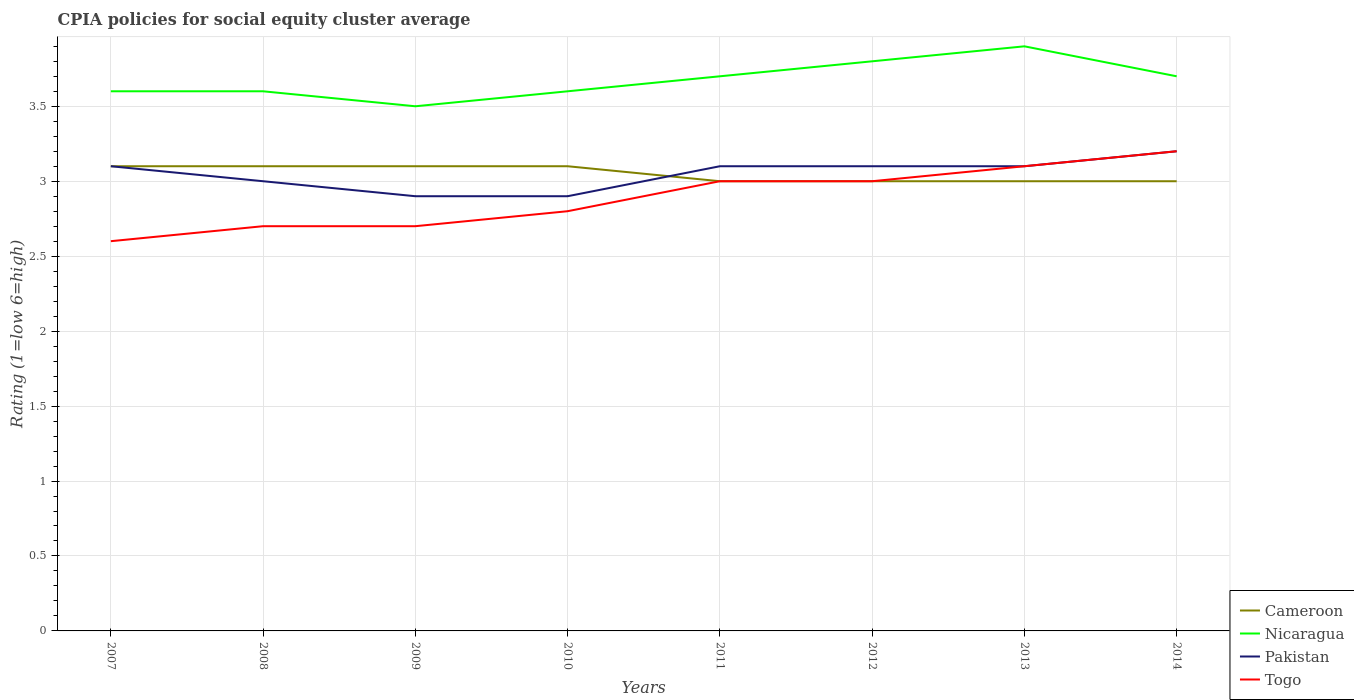How many different coloured lines are there?
Offer a terse response. 4. Does the line corresponding to Togo intersect with the line corresponding to Cameroon?
Make the answer very short. Yes. What is the difference between the highest and the second highest CPIA rating in Cameroon?
Your answer should be compact. 0.1. What is the difference between the highest and the lowest CPIA rating in Nicaragua?
Keep it short and to the point. 4. How many lines are there?
Offer a very short reply. 4. Are the values on the major ticks of Y-axis written in scientific E-notation?
Offer a terse response. No. Does the graph contain any zero values?
Your response must be concise. No. Does the graph contain grids?
Your response must be concise. Yes. How many legend labels are there?
Your response must be concise. 4. How are the legend labels stacked?
Provide a succinct answer. Vertical. What is the title of the graph?
Your answer should be very brief. CPIA policies for social equity cluster average. What is the label or title of the X-axis?
Your response must be concise. Years. What is the Rating (1=low 6=high) of Cameroon in 2007?
Provide a short and direct response. 3.1. What is the Rating (1=low 6=high) of Nicaragua in 2007?
Ensure brevity in your answer.  3.6. What is the Rating (1=low 6=high) in Togo in 2007?
Ensure brevity in your answer.  2.6. What is the Rating (1=low 6=high) of Cameroon in 2008?
Offer a very short reply. 3.1. What is the Rating (1=low 6=high) of Togo in 2008?
Offer a terse response. 2.7. What is the Rating (1=low 6=high) in Cameroon in 2009?
Your response must be concise. 3.1. What is the Rating (1=low 6=high) in Nicaragua in 2009?
Your response must be concise. 3.5. What is the Rating (1=low 6=high) in Pakistan in 2009?
Make the answer very short. 2.9. What is the Rating (1=low 6=high) in Togo in 2009?
Your answer should be compact. 2.7. What is the Rating (1=low 6=high) of Cameroon in 2010?
Make the answer very short. 3.1. What is the Rating (1=low 6=high) of Nicaragua in 2010?
Ensure brevity in your answer.  3.6. What is the Rating (1=low 6=high) of Togo in 2010?
Give a very brief answer. 2.8. What is the Rating (1=low 6=high) of Nicaragua in 2011?
Provide a short and direct response. 3.7. What is the Rating (1=low 6=high) of Nicaragua in 2012?
Your answer should be very brief. 3.8. What is the Rating (1=low 6=high) of Pakistan in 2012?
Provide a short and direct response. 3.1. What is the Rating (1=low 6=high) in Togo in 2012?
Offer a very short reply. 3. What is the Rating (1=low 6=high) of Cameroon in 2013?
Provide a succinct answer. 3. What is the Rating (1=low 6=high) in Nicaragua in 2014?
Your answer should be compact. 3.7. Across all years, what is the maximum Rating (1=low 6=high) in Nicaragua?
Provide a short and direct response. 3.9. Across all years, what is the minimum Rating (1=low 6=high) of Togo?
Make the answer very short. 2.6. What is the total Rating (1=low 6=high) in Cameroon in the graph?
Offer a very short reply. 24.4. What is the total Rating (1=low 6=high) of Nicaragua in the graph?
Provide a short and direct response. 29.4. What is the total Rating (1=low 6=high) of Pakistan in the graph?
Your answer should be compact. 24.4. What is the total Rating (1=low 6=high) of Togo in the graph?
Offer a very short reply. 23.1. What is the difference between the Rating (1=low 6=high) of Cameroon in 2007 and that in 2009?
Ensure brevity in your answer.  0. What is the difference between the Rating (1=low 6=high) in Togo in 2007 and that in 2009?
Your response must be concise. -0.1. What is the difference between the Rating (1=low 6=high) in Cameroon in 2007 and that in 2010?
Ensure brevity in your answer.  0. What is the difference between the Rating (1=low 6=high) of Cameroon in 2007 and that in 2011?
Provide a short and direct response. 0.1. What is the difference between the Rating (1=low 6=high) in Pakistan in 2007 and that in 2011?
Your answer should be compact. 0. What is the difference between the Rating (1=low 6=high) of Togo in 2007 and that in 2011?
Offer a very short reply. -0.4. What is the difference between the Rating (1=low 6=high) of Cameroon in 2007 and that in 2012?
Offer a very short reply. 0.1. What is the difference between the Rating (1=low 6=high) in Nicaragua in 2007 and that in 2012?
Your answer should be compact. -0.2. What is the difference between the Rating (1=low 6=high) in Pakistan in 2007 and that in 2012?
Ensure brevity in your answer.  0. What is the difference between the Rating (1=low 6=high) in Nicaragua in 2007 and that in 2013?
Keep it short and to the point. -0.3. What is the difference between the Rating (1=low 6=high) of Cameroon in 2007 and that in 2014?
Provide a succinct answer. 0.1. What is the difference between the Rating (1=low 6=high) in Cameroon in 2008 and that in 2009?
Provide a succinct answer. 0. What is the difference between the Rating (1=low 6=high) in Nicaragua in 2008 and that in 2009?
Make the answer very short. 0.1. What is the difference between the Rating (1=low 6=high) in Togo in 2008 and that in 2009?
Provide a succinct answer. 0. What is the difference between the Rating (1=low 6=high) in Nicaragua in 2008 and that in 2010?
Make the answer very short. 0. What is the difference between the Rating (1=low 6=high) of Cameroon in 2008 and that in 2011?
Ensure brevity in your answer.  0.1. What is the difference between the Rating (1=low 6=high) in Cameroon in 2008 and that in 2012?
Make the answer very short. 0.1. What is the difference between the Rating (1=low 6=high) in Pakistan in 2008 and that in 2012?
Make the answer very short. -0.1. What is the difference between the Rating (1=low 6=high) of Togo in 2008 and that in 2012?
Your answer should be very brief. -0.3. What is the difference between the Rating (1=low 6=high) of Cameroon in 2008 and that in 2013?
Keep it short and to the point. 0.1. What is the difference between the Rating (1=low 6=high) of Pakistan in 2008 and that in 2013?
Keep it short and to the point. -0.1. What is the difference between the Rating (1=low 6=high) in Cameroon in 2008 and that in 2014?
Your answer should be compact. 0.1. What is the difference between the Rating (1=low 6=high) in Nicaragua in 2008 and that in 2014?
Provide a succinct answer. -0.1. What is the difference between the Rating (1=low 6=high) in Pakistan in 2009 and that in 2010?
Your response must be concise. 0. What is the difference between the Rating (1=low 6=high) of Cameroon in 2009 and that in 2011?
Keep it short and to the point. 0.1. What is the difference between the Rating (1=low 6=high) in Nicaragua in 2009 and that in 2011?
Provide a succinct answer. -0.2. What is the difference between the Rating (1=low 6=high) of Pakistan in 2009 and that in 2011?
Make the answer very short. -0.2. What is the difference between the Rating (1=low 6=high) of Togo in 2009 and that in 2011?
Your response must be concise. -0.3. What is the difference between the Rating (1=low 6=high) in Cameroon in 2009 and that in 2012?
Offer a very short reply. 0.1. What is the difference between the Rating (1=low 6=high) in Nicaragua in 2009 and that in 2012?
Keep it short and to the point. -0.3. What is the difference between the Rating (1=low 6=high) in Pakistan in 2009 and that in 2012?
Provide a short and direct response. -0.2. What is the difference between the Rating (1=low 6=high) of Nicaragua in 2009 and that in 2013?
Make the answer very short. -0.4. What is the difference between the Rating (1=low 6=high) of Pakistan in 2009 and that in 2013?
Offer a terse response. -0.2. What is the difference between the Rating (1=low 6=high) of Togo in 2009 and that in 2013?
Provide a succinct answer. -0.4. What is the difference between the Rating (1=low 6=high) of Pakistan in 2009 and that in 2014?
Ensure brevity in your answer.  -0.3. What is the difference between the Rating (1=low 6=high) in Togo in 2009 and that in 2014?
Give a very brief answer. -0.5. What is the difference between the Rating (1=low 6=high) of Nicaragua in 2010 and that in 2011?
Keep it short and to the point. -0.1. What is the difference between the Rating (1=low 6=high) in Pakistan in 2010 and that in 2011?
Your answer should be very brief. -0.2. What is the difference between the Rating (1=low 6=high) of Togo in 2010 and that in 2011?
Provide a succinct answer. -0.2. What is the difference between the Rating (1=low 6=high) in Nicaragua in 2010 and that in 2012?
Provide a short and direct response. -0.2. What is the difference between the Rating (1=low 6=high) in Nicaragua in 2010 and that in 2013?
Your answer should be very brief. -0.3. What is the difference between the Rating (1=low 6=high) in Pakistan in 2010 and that in 2013?
Offer a very short reply. -0.2. What is the difference between the Rating (1=low 6=high) of Cameroon in 2010 and that in 2014?
Offer a terse response. 0.1. What is the difference between the Rating (1=low 6=high) of Pakistan in 2010 and that in 2014?
Your answer should be very brief. -0.3. What is the difference between the Rating (1=low 6=high) of Cameroon in 2011 and that in 2012?
Provide a short and direct response. 0. What is the difference between the Rating (1=low 6=high) of Nicaragua in 2011 and that in 2012?
Your answer should be very brief. -0.1. What is the difference between the Rating (1=low 6=high) of Pakistan in 2011 and that in 2012?
Make the answer very short. 0. What is the difference between the Rating (1=low 6=high) in Togo in 2011 and that in 2012?
Provide a succinct answer. 0. What is the difference between the Rating (1=low 6=high) of Cameroon in 2011 and that in 2014?
Ensure brevity in your answer.  0. What is the difference between the Rating (1=low 6=high) in Togo in 2012 and that in 2013?
Keep it short and to the point. -0.1. What is the difference between the Rating (1=low 6=high) of Cameroon in 2012 and that in 2014?
Provide a succinct answer. 0. What is the difference between the Rating (1=low 6=high) in Nicaragua in 2012 and that in 2014?
Keep it short and to the point. 0.1. What is the difference between the Rating (1=low 6=high) of Togo in 2012 and that in 2014?
Ensure brevity in your answer.  -0.2. What is the difference between the Rating (1=low 6=high) of Nicaragua in 2013 and that in 2014?
Keep it short and to the point. 0.2. What is the difference between the Rating (1=low 6=high) of Pakistan in 2013 and that in 2014?
Your answer should be very brief. -0.1. What is the difference between the Rating (1=low 6=high) of Togo in 2013 and that in 2014?
Offer a terse response. -0.1. What is the difference between the Rating (1=low 6=high) of Cameroon in 2007 and the Rating (1=low 6=high) of Pakistan in 2008?
Give a very brief answer. 0.1. What is the difference between the Rating (1=low 6=high) of Cameroon in 2007 and the Rating (1=low 6=high) of Togo in 2008?
Offer a terse response. 0.4. What is the difference between the Rating (1=low 6=high) of Nicaragua in 2007 and the Rating (1=low 6=high) of Pakistan in 2008?
Offer a terse response. 0.6. What is the difference between the Rating (1=low 6=high) of Nicaragua in 2007 and the Rating (1=low 6=high) of Togo in 2008?
Provide a short and direct response. 0.9. What is the difference between the Rating (1=low 6=high) in Cameroon in 2007 and the Rating (1=low 6=high) in Nicaragua in 2010?
Your answer should be very brief. -0.5. What is the difference between the Rating (1=low 6=high) of Cameroon in 2007 and the Rating (1=low 6=high) of Togo in 2010?
Provide a short and direct response. 0.3. What is the difference between the Rating (1=low 6=high) of Nicaragua in 2007 and the Rating (1=low 6=high) of Togo in 2010?
Give a very brief answer. 0.8. What is the difference between the Rating (1=low 6=high) in Pakistan in 2007 and the Rating (1=low 6=high) in Togo in 2010?
Offer a very short reply. 0.3. What is the difference between the Rating (1=low 6=high) in Nicaragua in 2007 and the Rating (1=low 6=high) in Pakistan in 2011?
Your answer should be very brief. 0.5. What is the difference between the Rating (1=low 6=high) of Cameroon in 2007 and the Rating (1=low 6=high) of Nicaragua in 2012?
Ensure brevity in your answer.  -0.7. What is the difference between the Rating (1=low 6=high) of Cameroon in 2007 and the Rating (1=low 6=high) of Togo in 2012?
Your answer should be very brief. 0.1. What is the difference between the Rating (1=low 6=high) in Pakistan in 2007 and the Rating (1=low 6=high) in Togo in 2012?
Keep it short and to the point. 0.1. What is the difference between the Rating (1=low 6=high) in Cameroon in 2007 and the Rating (1=low 6=high) in Pakistan in 2013?
Provide a short and direct response. 0. What is the difference between the Rating (1=low 6=high) of Cameroon in 2007 and the Rating (1=low 6=high) of Togo in 2013?
Give a very brief answer. 0. What is the difference between the Rating (1=low 6=high) in Nicaragua in 2007 and the Rating (1=low 6=high) in Pakistan in 2013?
Your answer should be compact. 0.5. What is the difference between the Rating (1=low 6=high) of Pakistan in 2007 and the Rating (1=low 6=high) of Togo in 2013?
Keep it short and to the point. 0. What is the difference between the Rating (1=low 6=high) of Cameroon in 2007 and the Rating (1=low 6=high) of Nicaragua in 2014?
Provide a short and direct response. -0.6. What is the difference between the Rating (1=low 6=high) in Cameroon in 2007 and the Rating (1=low 6=high) in Togo in 2014?
Keep it short and to the point. -0.1. What is the difference between the Rating (1=low 6=high) in Nicaragua in 2007 and the Rating (1=low 6=high) in Togo in 2014?
Your response must be concise. 0.4. What is the difference between the Rating (1=low 6=high) in Pakistan in 2007 and the Rating (1=low 6=high) in Togo in 2014?
Ensure brevity in your answer.  -0.1. What is the difference between the Rating (1=low 6=high) of Cameroon in 2008 and the Rating (1=low 6=high) of Pakistan in 2009?
Your answer should be compact. 0.2. What is the difference between the Rating (1=low 6=high) in Cameroon in 2008 and the Rating (1=low 6=high) in Togo in 2009?
Offer a terse response. 0.4. What is the difference between the Rating (1=low 6=high) in Nicaragua in 2008 and the Rating (1=low 6=high) in Togo in 2009?
Your answer should be compact. 0.9. What is the difference between the Rating (1=low 6=high) of Pakistan in 2008 and the Rating (1=low 6=high) of Togo in 2009?
Your answer should be very brief. 0.3. What is the difference between the Rating (1=low 6=high) in Nicaragua in 2008 and the Rating (1=low 6=high) in Pakistan in 2010?
Your answer should be compact. 0.7. What is the difference between the Rating (1=low 6=high) in Pakistan in 2008 and the Rating (1=low 6=high) in Togo in 2010?
Make the answer very short. 0.2. What is the difference between the Rating (1=low 6=high) of Cameroon in 2008 and the Rating (1=low 6=high) of Pakistan in 2011?
Offer a terse response. 0. What is the difference between the Rating (1=low 6=high) in Cameroon in 2008 and the Rating (1=low 6=high) in Togo in 2011?
Ensure brevity in your answer.  0.1. What is the difference between the Rating (1=low 6=high) in Nicaragua in 2008 and the Rating (1=low 6=high) in Togo in 2011?
Provide a short and direct response. 0.6. What is the difference between the Rating (1=low 6=high) of Cameroon in 2008 and the Rating (1=low 6=high) of Nicaragua in 2012?
Keep it short and to the point. -0.7. What is the difference between the Rating (1=low 6=high) in Cameroon in 2008 and the Rating (1=low 6=high) in Pakistan in 2012?
Your response must be concise. 0. What is the difference between the Rating (1=low 6=high) in Cameroon in 2008 and the Rating (1=low 6=high) in Togo in 2012?
Your response must be concise. 0.1. What is the difference between the Rating (1=low 6=high) in Nicaragua in 2008 and the Rating (1=low 6=high) in Togo in 2012?
Ensure brevity in your answer.  0.6. What is the difference between the Rating (1=low 6=high) of Pakistan in 2008 and the Rating (1=low 6=high) of Togo in 2012?
Provide a succinct answer. 0. What is the difference between the Rating (1=low 6=high) of Cameroon in 2008 and the Rating (1=low 6=high) of Nicaragua in 2013?
Make the answer very short. -0.8. What is the difference between the Rating (1=low 6=high) of Nicaragua in 2008 and the Rating (1=low 6=high) of Togo in 2013?
Give a very brief answer. 0.5. What is the difference between the Rating (1=low 6=high) of Pakistan in 2008 and the Rating (1=low 6=high) of Togo in 2013?
Provide a succinct answer. -0.1. What is the difference between the Rating (1=low 6=high) of Cameroon in 2008 and the Rating (1=low 6=high) of Togo in 2014?
Provide a succinct answer. -0.1. What is the difference between the Rating (1=low 6=high) in Pakistan in 2008 and the Rating (1=low 6=high) in Togo in 2014?
Your answer should be very brief. -0.2. What is the difference between the Rating (1=low 6=high) in Cameroon in 2009 and the Rating (1=low 6=high) in Pakistan in 2010?
Your answer should be compact. 0.2. What is the difference between the Rating (1=low 6=high) in Cameroon in 2009 and the Rating (1=low 6=high) in Togo in 2010?
Ensure brevity in your answer.  0.3. What is the difference between the Rating (1=low 6=high) in Pakistan in 2009 and the Rating (1=low 6=high) in Togo in 2010?
Your response must be concise. 0.1. What is the difference between the Rating (1=low 6=high) of Nicaragua in 2009 and the Rating (1=low 6=high) of Pakistan in 2011?
Ensure brevity in your answer.  0.4. What is the difference between the Rating (1=low 6=high) in Pakistan in 2009 and the Rating (1=low 6=high) in Togo in 2011?
Your response must be concise. -0.1. What is the difference between the Rating (1=low 6=high) of Cameroon in 2009 and the Rating (1=low 6=high) of Pakistan in 2012?
Offer a very short reply. 0. What is the difference between the Rating (1=low 6=high) of Cameroon in 2009 and the Rating (1=low 6=high) of Togo in 2012?
Make the answer very short. 0.1. What is the difference between the Rating (1=low 6=high) of Nicaragua in 2009 and the Rating (1=low 6=high) of Togo in 2012?
Make the answer very short. 0.5. What is the difference between the Rating (1=low 6=high) of Cameroon in 2009 and the Rating (1=low 6=high) of Nicaragua in 2013?
Make the answer very short. -0.8. What is the difference between the Rating (1=low 6=high) in Nicaragua in 2009 and the Rating (1=low 6=high) in Pakistan in 2013?
Give a very brief answer. 0.4. What is the difference between the Rating (1=low 6=high) of Nicaragua in 2009 and the Rating (1=low 6=high) of Togo in 2013?
Give a very brief answer. 0.4. What is the difference between the Rating (1=low 6=high) of Pakistan in 2009 and the Rating (1=low 6=high) of Togo in 2013?
Your answer should be very brief. -0.2. What is the difference between the Rating (1=low 6=high) of Cameroon in 2009 and the Rating (1=low 6=high) of Nicaragua in 2014?
Ensure brevity in your answer.  -0.6. What is the difference between the Rating (1=low 6=high) in Cameroon in 2009 and the Rating (1=low 6=high) in Pakistan in 2014?
Offer a very short reply. -0.1. What is the difference between the Rating (1=low 6=high) of Cameroon in 2009 and the Rating (1=low 6=high) of Togo in 2014?
Your answer should be compact. -0.1. What is the difference between the Rating (1=low 6=high) of Cameroon in 2010 and the Rating (1=low 6=high) of Nicaragua in 2011?
Ensure brevity in your answer.  -0.6. What is the difference between the Rating (1=low 6=high) of Cameroon in 2010 and the Rating (1=low 6=high) of Pakistan in 2011?
Your answer should be very brief. 0. What is the difference between the Rating (1=low 6=high) of Nicaragua in 2010 and the Rating (1=low 6=high) of Pakistan in 2011?
Provide a succinct answer. 0.5. What is the difference between the Rating (1=low 6=high) of Pakistan in 2010 and the Rating (1=low 6=high) of Togo in 2011?
Make the answer very short. -0.1. What is the difference between the Rating (1=low 6=high) in Cameroon in 2010 and the Rating (1=low 6=high) in Nicaragua in 2012?
Make the answer very short. -0.7. What is the difference between the Rating (1=low 6=high) in Nicaragua in 2010 and the Rating (1=low 6=high) in Pakistan in 2012?
Provide a succinct answer. 0.5. What is the difference between the Rating (1=low 6=high) of Nicaragua in 2010 and the Rating (1=low 6=high) of Togo in 2012?
Ensure brevity in your answer.  0.6. What is the difference between the Rating (1=low 6=high) of Cameroon in 2010 and the Rating (1=low 6=high) of Nicaragua in 2014?
Make the answer very short. -0.6. What is the difference between the Rating (1=low 6=high) in Cameroon in 2010 and the Rating (1=low 6=high) in Pakistan in 2014?
Make the answer very short. -0.1. What is the difference between the Rating (1=low 6=high) in Cameroon in 2010 and the Rating (1=low 6=high) in Togo in 2014?
Provide a succinct answer. -0.1. What is the difference between the Rating (1=low 6=high) in Pakistan in 2010 and the Rating (1=low 6=high) in Togo in 2014?
Ensure brevity in your answer.  -0.3. What is the difference between the Rating (1=low 6=high) in Cameroon in 2011 and the Rating (1=low 6=high) in Nicaragua in 2012?
Provide a short and direct response. -0.8. What is the difference between the Rating (1=low 6=high) of Cameroon in 2011 and the Rating (1=low 6=high) of Pakistan in 2012?
Provide a short and direct response. -0.1. What is the difference between the Rating (1=low 6=high) of Cameroon in 2011 and the Rating (1=low 6=high) of Togo in 2012?
Make the answer very short. 0. What is the difference between the Rating (1=low 6=high) in Nicaragua in 2011 and the Rating (1=low 6=high) in Pakistan in 2012?
Your response must be concise. 0.6. What is the difference between the Rating (1=low 6=high) in Nicaragua in 2011 and the Rating (1=low 6=high) in Togo in 2012?
Offer a very short reply. 0.7. What is the difference between the Rating (1=low 6=high) in Cameroon in 2011 and the Rating (1=low 6=high) in Nicaragua in 2013?
Your answer should be very brief. -0.9. What is the difference between the Rating (1=low 6=high) in Cameroon in 2011 and the Rating (1=low 6=high) in Togo in 2013?
Keep it short and to the point. -0.1. What is the difference between the Rating (1=low 6=high) of Cameroon in 2011 and the Rating (1=low 6=high) of Nicaragua in 2014?
Your answer should be compact. -0.7. What is the difference between the Rating (1=low 6=high) in Cameroon in 2011 and the Rating (1=low 6=high) in Togo in 2014?
Offer a very short reply. -0.2. What is the difference between the Rating (1=low 6=high) in Nicaragua in 2011 and the Rating (1=low 6=high) in Pakistan in 2014?
Provide a short and direct response. 0.5. What is the difference between the Rating (1=low 6=high) of Nicaragua in 2012 and the Rating (1=low 6=high) of Pakistan in 2013?
Your response must be concise. 0.7. What is the difference between the Rating (1=low 6=high) of Nicaragua in 2012 and the Rating (1=low 6=high) of Togo in 2013?
Offer a terse response. 0.7. What is the difference between the Rating (1=low 6=high) in Pakistan in 2012 and the Rating (1=low 6=high) in Togo in 2013?
Your answer should be very brief. 0. What is the difference between the Rating (1=low 6=high) of Cameroon in 2012 and the Rating (1=low 6=high) of Nicaragua in 2014?
Provide a succinct answer. -0.7. What is the difference between the Rating (1=low 6=high) of Cameroon in 2012 and the Rating (1=low 6=high) of Togo in 2014?
Provide a succinct answer. -0.2. What is the difference between the Rating (1=low 6=high) of Nicaragua in 2012 and the Rating (1=low 6=high) of Pakistan in 2014?
Keep it short and to the point. 0.6. What is the difference between the Rating (1=low 6=high) in Nicaragua in 2012 and the Rating (1=low 6=high) in Togo in 2014?
Offer a terse response. 0.6. What is the difference between the Rating (1=low 6=high) in Cameroon in 2013 and the Rating (1=low 6=high) in Nicaragua in 2014?
Your response must be concise. -0.7. What is the difference between the Rating (1=low 6=high) of Nicaragua in 2013 and the Rating (1=low 6=high) of Pakistan in 2014?
Give a very brief answer. 0.7. What is the difference between the Rating (1=low 6=high) in Pakistan in 2013 and the Rating (1=low 6=high) in Togo in 2014?
Your answer should be very brief. -0.1. What is the average Rating (1=low 6=high) in Cameroon per year?
Keep it short and to the point. 3.05. What is the average Rating (1=low 6=high) in Nicaragua per year?
Ensure brevity in your answer.  3.67. What is the average Rating (1=low 6=high) of Pakistan per year?
Provide a short and direct response. 3.05. What is the average Rating (1=low 6=high) of Togo per year?
Offer a very short reply. 2.89. In the year 2007, what is the difference between the Rating (1=low 6=high) in Cameroon and Rating (1=low 6=high) in Togo?
Keep it short and to the point. 0.5. In the year 2008, what is the difference between the Rating (1=low 6=high) of Cameroon and Rating (1=low 6=high) of Nicaragua?
Offer a very short reply. -0.5. In the year 2008, what is the difference between the Rating (1=low 6=high) of Cameroon and Rating (1=low 6=high) of Pakistan?
Provide a succinct answer. 0.1. In the year 2008, what is the difference between the Rating (1=low 6=high) of Nicaragua and Rating (1=low 6=high) of Togo?
Provide a succinct answer. 0.9. In the year 2009, what is the difference between the Rating (1=low 6=high) in Cameroon and Rating (1=low 6=high) in Nicaragua?
Your answer should be compact. -0.4. In the year 2009, what is the difference between the Rating (1=low 6=high) in Cameroon and Rating (1=low 6=high) in Pakistan?
Offer a very short reply. 0.2. In the year 2009, what is the difference between the Rating (1=low 6=high) in Cameroon and Rating (1=low 6=high) in Togo?
Provide a succinct answer. 0.4. In the year 2009, what is the difference between the Rating (1=low 6=high) in Nicaragua and Rating (1=low 6=high) in Pakistan?
Your answer should be compact. 0.6. In the year 2009, what is the difference between the Rating (1=low 6=high) of Nicaragua and Rating (1=low 6=high) of Togo?
Provide a short and direct response. 0.8. In the year 2010, what is the difference between the Rating (1=low 6=high) in Cameroon and Rating (1=low 6=high) in Pakistan?
Provide a short and direct response. 0.2. In the year 2010, what is the difference between the Rating (1=low 6=high) of Cameroon and Rating (1=low 6=high) of Togo?
Your answer should be very brief. 0.3. In the year 2010, what is the difference between the Rating (1=low 6=high) in Nicaragua and Rating (1=low 6=high) in Pakistan?
Your answer should be very brief. 0.7. In the year 2010, what is the difference between the Rating (1=low 6=high) of Nicaragua and Rating (1=low 6=high) of Togo?
Provide a short and direct response. 0.8. In the year 2010, what is the difference between the Rating (1=low 6=high) in Pakistan and Rating (1=low 6=high) in Togo?
Offer a very short reply. 0.1. In the year 2011, what is the difference between the Rating (1=low 6=high) of Cameroon and Rating (1=low 6=high) of Pakistan?
Your answer should be very brief. -0.1. In the year 2011, what is the difference between the Rating (1=low 6=high) in Nicaragua and Rating (1=low 6=high) in Pakistan?
Keep it short and to the point. 0.6. In the year 2012, what is the difference between the Rating (1=low 6=high) of Cameroon and Rating (1=low 6=high) of Pakistan?
Keep it short and to the point. -0.1. In the year 2012, what is the difference between the Rating (1=low 6=high) in Nicaragua and Rating (1=low 6=high) in Pakistan?
Keep it short and to the point. 0.7. In the year 2012, what is the difference between the Rating (1=low 6=high) of Nicaragua and Rating (1=low 6=high) of Togo?
Your answer should be compact. 0.8. In the year 2012, what is the difference between the Rating (1=low 6=high) of Pakistan and Rating (1=low 6=high) of Togo?
Keep it short and to the point. 0.1. In the year 2013, what is the difference between the Rating (1=low 6=high) in Cameroon and Rating (1=low 6=high) in Nicaragua?
Your answer should be very brief. -0.9. In the year 2013, what is the difference between the Rating (1=low 6=high) in Cameroon and Rating (1=low 6=high) in Pakistan?
Provide a succinct answer. -0.1. In the year 2013, what is the difference between the Rating (1=low 6=high) of Nicaragua and Rating (1=low 6=high) of Pakistan?
Make the answer very short. 0.8. In the year 2013, what is the difference between the Rating (1=low 6=high) in Nicaragua and Rating (1=low 6=high) in Togo?
Make the answer very short. 0.8. In the year 2013, what is the difference between the Rating (1=low 6=high) of Pakistan and Rating (1=low 6=high) of Togo?
Provide a short and direct response. 0. In the year 2014, what is the difference between the Rating (1=low 6=high) of Cameroon and Rating (1=low 6=high) of Nicaragua?
Keep it short and to the point. -0.7. In the year 2014, what is the difference between the Rating (1=low 6=high) of Cameroon and Rating (1=low 6=high) of Pakistan?
Provide a succinct answer. -0.2. In the year 2014, what is the difference between the Rating (1=low 6=high) of Cameroon and Rating (1=low 6=high) of Togo?
Your response must be concise. -0.2. In the year 2014, what is the difference between the Rating (1=low 6=high) of Nicaragua and Rating (1=low 6=high) of Togo?
Offer a very short reply. 0.5. In the year 2014, what is the difference between the Rating (1=low 6=high) in Pakistan and Rating (1=low 6=high) in Togo?
Provide a succinct answer. 0. What is the ratio of the Rating (1=low 6=high) of Pakistan in 2007 to that in 2008?
Provide a short and direct response. 1.03. What is the ratio of the Rating (1=low 6=high) in Nicaragua in 2007 to that in 2009?
Offer a terse response. 1.03. What is the ratio of the Rating (1=low 6=high) of Pakistan in 2007 to that in 2009?
Your response must be concise. 1.07. What is the ratio of the Rating (1=low 6=high) of Togo in 2007 to that in 2009?
Offer a very short reply. 0.96. What is the ratio of the Rating (1=low 6=high) of Pakistan in 2007 to that in 2010?
Provide a short and direct response. 1.07. What is the ratio of the Rating (1=low 6=high) of Togo in 2007 to that in 2010?
Make the answer very short. 0.93. What is the ratio of the Rating (1=low 6=high) of Cameroon in 2007 to that in 2011?
Ensure brevity in your answer.  1.03. What is the ratio of the Rating (1=low 6=high) in Nicaragua in 2007 to that in 2011?
Your answer should be compact. 0.97. What is the ratio of the Rating (1=low 6=high) of Pakistan in 2007 to that in 2011?
Give a very brief answer. 1. What is the ratio of the Rating (1=low 6=high) in Togo in 2007 to that in 2011?
Your answer should be compact. 0.87. What is the ratio of the Rating (1=low 6=high) of Nicaragua in 2007 to that in 2012?
Provide a short and direct response. 0.95. What is the ratio of the Rating (1=low 6=high) in Pakistan in 2007 to that in 2012?
Ensure brevity in your answer.  1. What is the ratio of the Rating (1=low 6=high) of Togo in 2007 to that in 2012?
Keep it short and to the point. 0.87. What is the ratio of the Rating (1=low 6=high) of Nicaragua in 2007 to that in 2013?
Give a very brief answer. 0.92. What is the ratio of the Rating (1=low 6=high) of Pakistan in 2007 to that in 2013?
Provide a short and direct response. 1. What is the ratio of the Rating (1=low 6=high) in Togo in 2007 to that in 2013?
Make the answer very short. 0.84. What is the ratio of the Rating (1=low 6=high) in Nicaragua in 2007 to that in 2014?
Your answer should be very brief. 0.97. What is the ratio of the Rating (1=low 6=high) in Pakistan in 2007 to that in 2014?
Your answer should be compact. 0.97. What is the ratio of the Rating (1=low 6=high) in Togo in 2007 to that in 2014?
Your answer should be compact. 0.81. What is the ratio of the Rating (1=low 6=high) in Cameroon in 2008 to that in 2009?
Provide a short and direct response. 1. What is the ratio of the Rating (1=low 6=high) in Nicaragua in 2008 to that in 2009?
Keep it short and to the point. 1.03. What is the ratio of the Rating (1=low 6=high) in Pakistan in 2008 to that in 2009?
Give a very brief answer. 1.03. What is the ratio of the Rating (1=low 6=high) of Togo in 2008 to that in 2009?
Offer a very short reply. 1. What is the ratio of the Rating (1=low 6=high) in Nicaragua in 2008 to that in 2010?
Offer a very short reply. 1. What is the ratio of the Rating (1=low 6=high) of Pakistan in 2008 to that in 2010?
Ensure brevity in your answer.  1.03. What is the ratio of the Rating (1=low 6=high) in Togo in 2008 to that in 2010?
Keep it short and to the point. 0.96. What is the ratio of the Rating (1=low 6=high) of Cameroon in 2008 to that in 2011?
Your answer should be compact. 1.03. What is the ratio of the Rating (1=low 6=high) in Nicaragua in 2008 to that in 2011?
Your answer should be very brief. 0.97. What is the ratio of the Rating (1=low 6=high) of Togo in 2008 to that in 2011?
Keep it short and to the point. 0.9. What is the ratio of the Rating (1=low 6=high) in Pakistan in 2008 to that in 2012?
Offer a terse response. 0.97. What is the ratio of the Rating (1=low 6=high) in Nicaragua in 2008 to that in 2013?
Provide a short and direct response. 0.92. What is the ratio of the Rating (1=low 6=high) of Pakistan in 2008 to that in 2013?
Keep it short and to the point. 0.97. What is the ratio of the Rating (1=low 6=high) in Togo in 2008 to that in 2013?
Your answer should be compact. 0.87. What is the ratio of the Rating (1=low 6=high) in Cameroon in 2008 to that in 2014?
Your answer should be compact. 1.03. What is the ratio of the Rating (1=low 6=high) of Pakistan in 2008 to that in 2014?
Offer a terse response. 0.94. What is the ratio of the Rating (1=low 6=high) in Togo in 2008 to that in 2014?
Your answer should be very brief. 0.84. What is the ratio of the Rating (1=low 6=high) of Nicaragua in 2009 to that in 2010?
Ensure brevity in your answer.  0.97. What is the ratio of the Rating (1=low 6=high) in Pakistan in 2009 to that in 2010?
Offer a terse response. 1. What is the ratio of the Rating (1=low 6=high) in Nicaragua in 2009 to that in 2011?
Offer a terse response. 0.95. What is the ratio of the Rating (1=low 6=high) in Pakistan in 2009 to that in 2011?
Make the answer very short. 0.94. What is the ratio of the Rating (1=low 6=high) in Togo in 2009 to that in 2011?
Provide a succinct answer. 0.9. What is the ratio of the Rating (1=low 6=high) of Nicaragua in 2009 to that in 2012?
Your answer should be very brief. 0.92. What is the ratio of the Rating (1=low 6=high) in Pakistan in 2009 to that in 2012?
Make the answer very short. 0.94. What is the ratio of the Rating (1=low 6=high) in Togo in 2009 to that in 2012?
Provide a succinct answer. 0.9. What is the ratio of the Rating (1=low 6=high) of Nicaragua in 2009 to that in 2013?
Give a very brief answer. 0.9. What is the ratio of the Rating (1=low 6=high) in Pakistan in 2009 to that in 2013?
Provide a succinct answer. 0.94. What is the ratio of the Rating (1=low 6=high) in Togo in 2009 to that in 2013?
Give a very brief answer. 0.87. What is the ratio of the Rating (1=low 6=high) of Nicaragua in 2009 to that in 2014?
Your answer should be compact. 0.95. What is the ratio of the Rating (1=low 6=high) of Pakistan in 2009 to that in 2014?
Make the answer very short. 0.91. What is the ratio of the Rating (1=low 6=high) of Togo in 2009 to that in 2014?
Offer a very short reply. 0.84. What is the ratio of the Rating (1=low 6=high) in Cameroon in 2010 to that in 2011?
Provide a short and direct response. 1.03. What is the ratio of the Rating (1=low 6=high) of Nicaragua in 2010 to that in 2011?
Provide a succinct answer. 0.97. What is the ratio of the Rating (1=low 6=high) of Pakistan in 2010 to that in 2011?
Provide a succinct answer. 0.94. What is the ratio of the Rating (1=low 6=high) of Togo in 2010 to that in 2011?
Give a very brief answer. 0.93. What is the ratio of the Rating (1=low 6=high) of Cameroon in 2010 to that in 2012?
Make the answer very short. 1.03. What is the ratio of the Rating (1=low 6=high) in Pakistan in 2010 to that in 2012?
Give a very brief answer. 0.94. What is the ratio of the Rating (1=low 6=high) of Togo in 2010 to that in 2012?
Ensure brevity in your answer.  0.93. What is the ratio of the Rating (1=low 6=high) of Pakistan in 2010 to that in 2013?
Your answer should be compact. 0.94. What is the ratio of the Rating (1=low 6=high) in Togo in 2010 to that in 2013?
Provide a succinct answer. 0.9. What is the ratio of the Rating (1=low 6=high) of Cameroon in 2010 to that in 2014?
Give a very brief answer. 1.03. What is the ratio of the Rating (1=low 6=high) of Pakistan in 2010 to that in 2014?
Keep it short and to the point. 0.91. What is the ratio of the Rating (1=low 6=high) in Cameroon in 2011 to that in 2012?
Keep it short and to the point. 1. What is the ratio of the Rating (1=low 6=high) in Nicaragua in 2011 to that in 2012?
Your response must be concise. 0.97. What is the ratio of the Rating (1=low 6=high) of Cameroon in 2011 to that in 2013?
Provide a short and direct response. 1. What is the ratio of the Rating (1=low 6=high) in Nicaragua in 2011 to that in 2013?
Give a very brief answer. 0.95. What is the ratio of the Rating (1=low 6=high) in Nicaragua in 2011 to that in 2014?
Provide a short and direct response. 1. What is the ratio of the Rating (1=low 6=high) in Pakistan in 2011 to that in 2014?
Offer a very short reply. 0.97. What is the ratio of the Rating (1=low 6=high) in Togo in 2011 to that in 2014?
Keep it short and to the point. 0.94. What is the ratio of the Rating (1=low 6=high) in Nicaragua in 2012 to that in 2013?
Keep it short and to the point. 0.97. What is the ratio of the Rating (1=low 6=high) of Togo in 2012 to that in 2013?
Your response must be concise. 0.97. What is the ratio of the Rating (1=low 6=high) in Pakistan in 2012 to that in 2014?
Ensure brevity in your answer.  0.97. What is the ratio of the Rating (1=low 6=high) in Cameroon in 2013 to that in 2014?
Give a very brief answer. 1. What is the ratio of the Rating (1=low 6=high) of Nicaragua in 2013 to that in 2014?
Offer a very short reply. 1.05. What is the ratio of the Rating (1=low 6=high) of Pakistan in 2013 to that in 2014?
Your answer should be very brief. 0.97. What is the ratio of the Rating (1=low 6=high) in Togo in 2013 to that in 2014?
Your response must be concise. 0.97. What is the difference between the highest and the second highest Rating (1=low 6=high) of Cameroon?
Provide a short and direct response. 0. What is the difference between the highest and the second highest Rating (1=low 6=high) of Pakistan?
Keep it short and to the point. 0.1. What is the difference between the highest and the lowest Rating (1=low 6=high) in Nicaragua?
Your answer should be very brief. 0.4. 